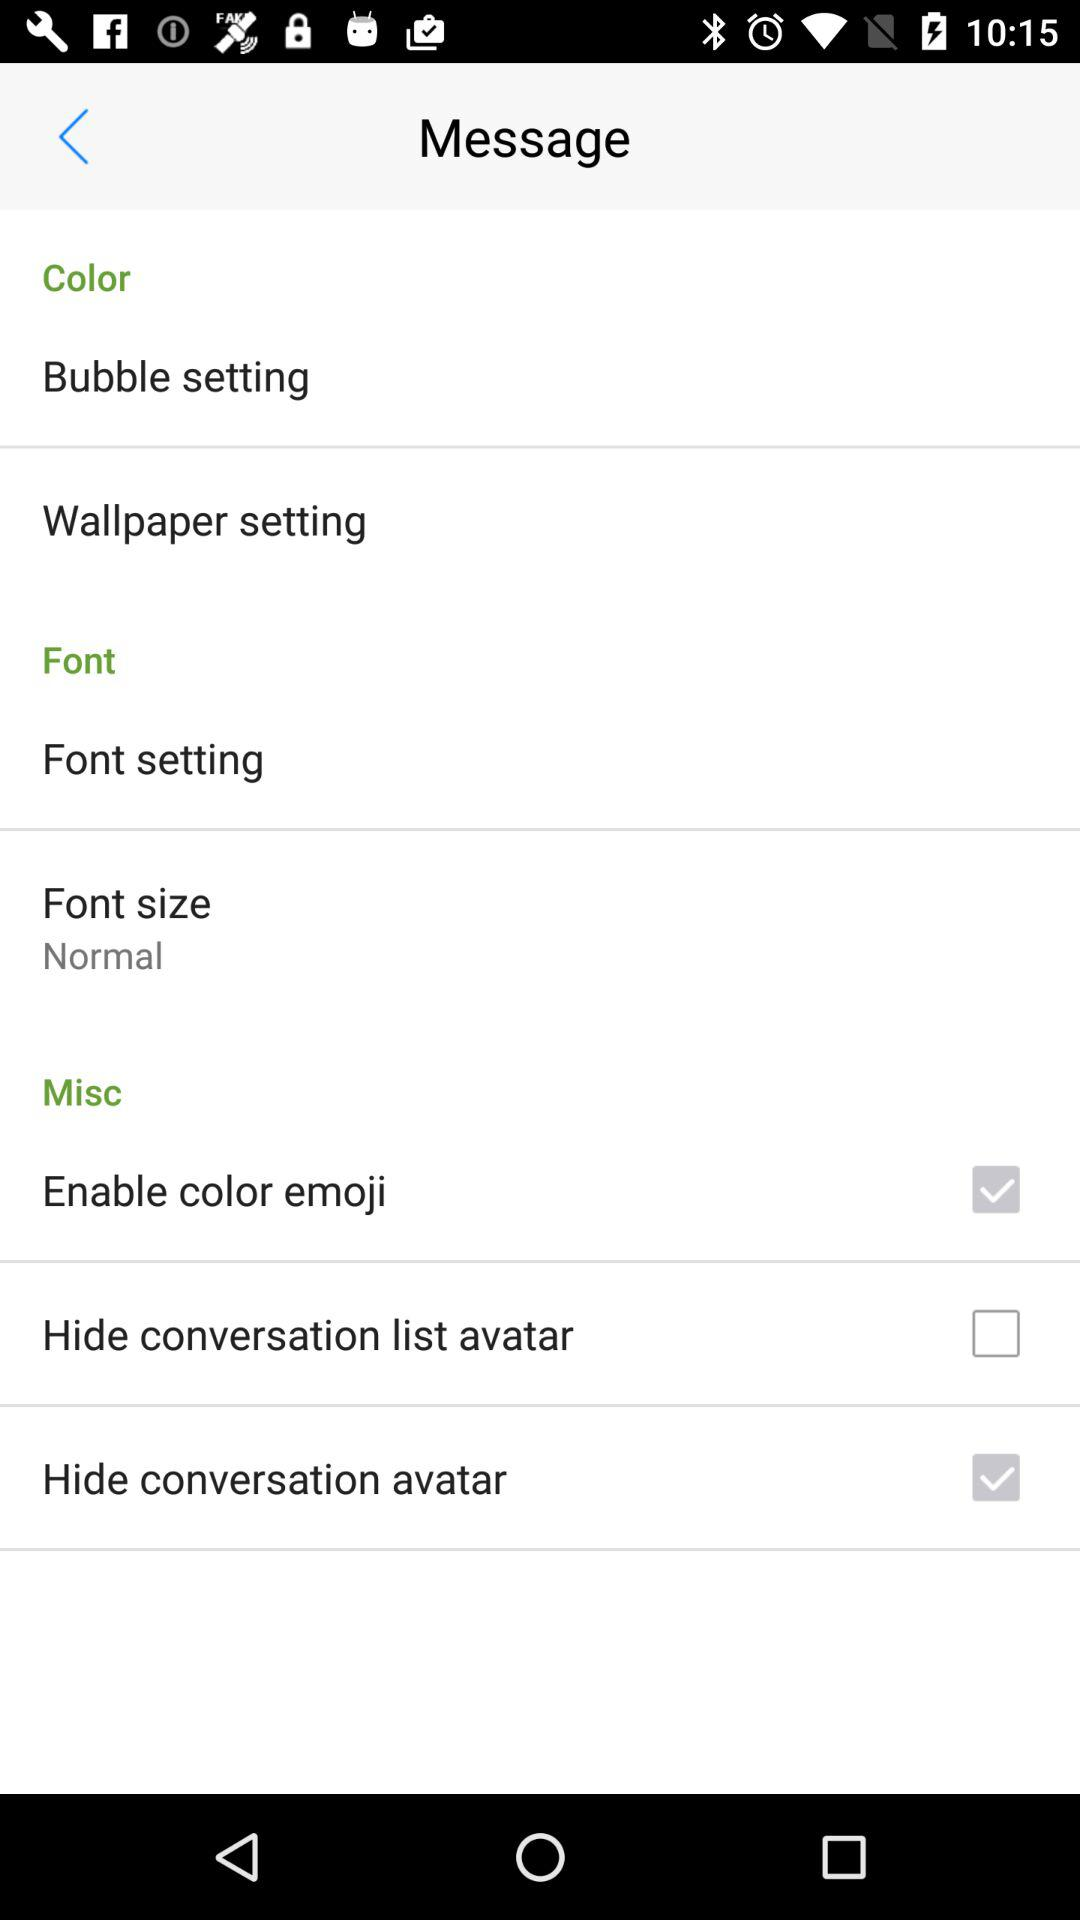What is the font size? The font size is "Normal". 